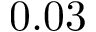Convert formula to latex. <formula><loc_0><loc_0><loc_500><loc_500>0 . 0 3</formula> 